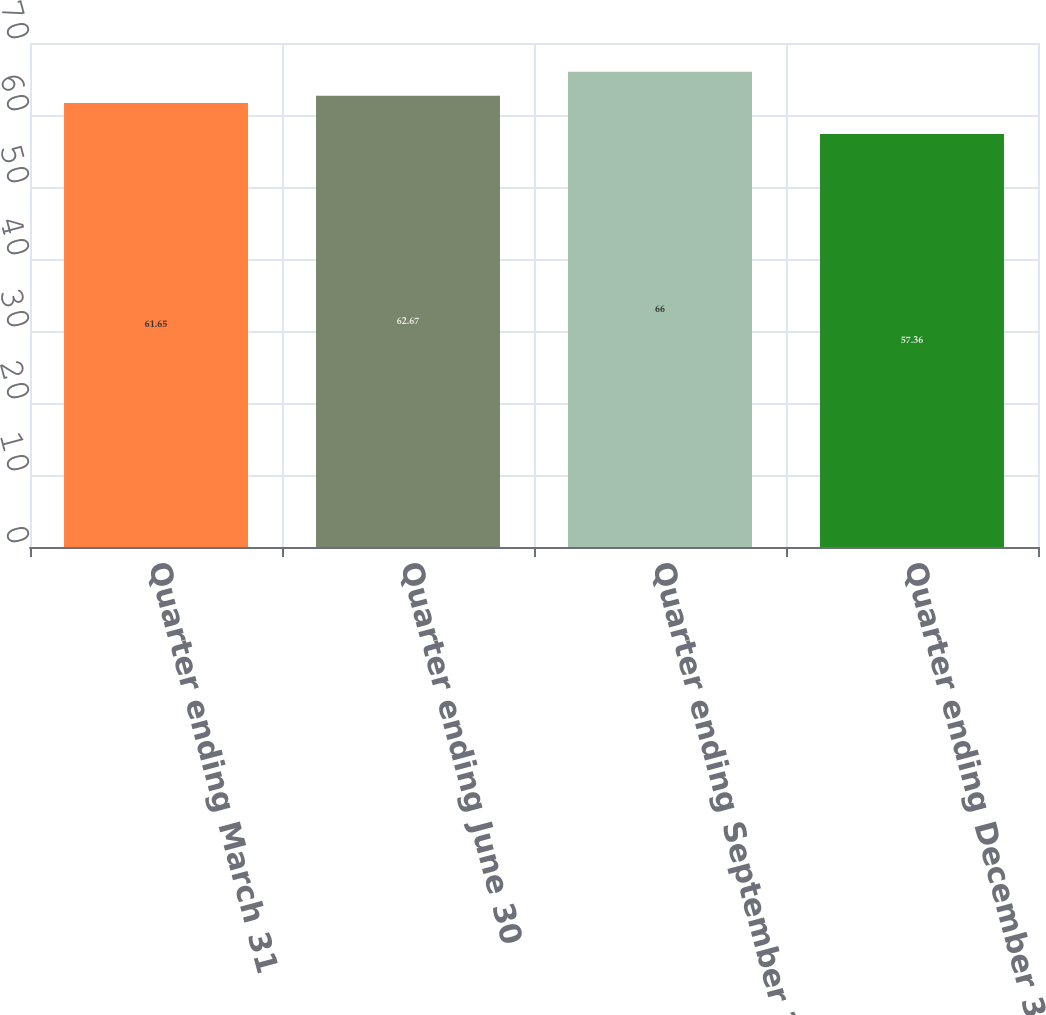Convert chart. <chart><loc_0><loc_0><loc_500><loc_500><bar_chart><fcel>Quarter ending March 31<fcel>Quarter ending June 30<fcel>Quarter ending September 30<fcel>Quarter ending December 31<nl><fcel>61.65<fcel>62.67<fcel>66<fcel>57.36<nl></chart> 